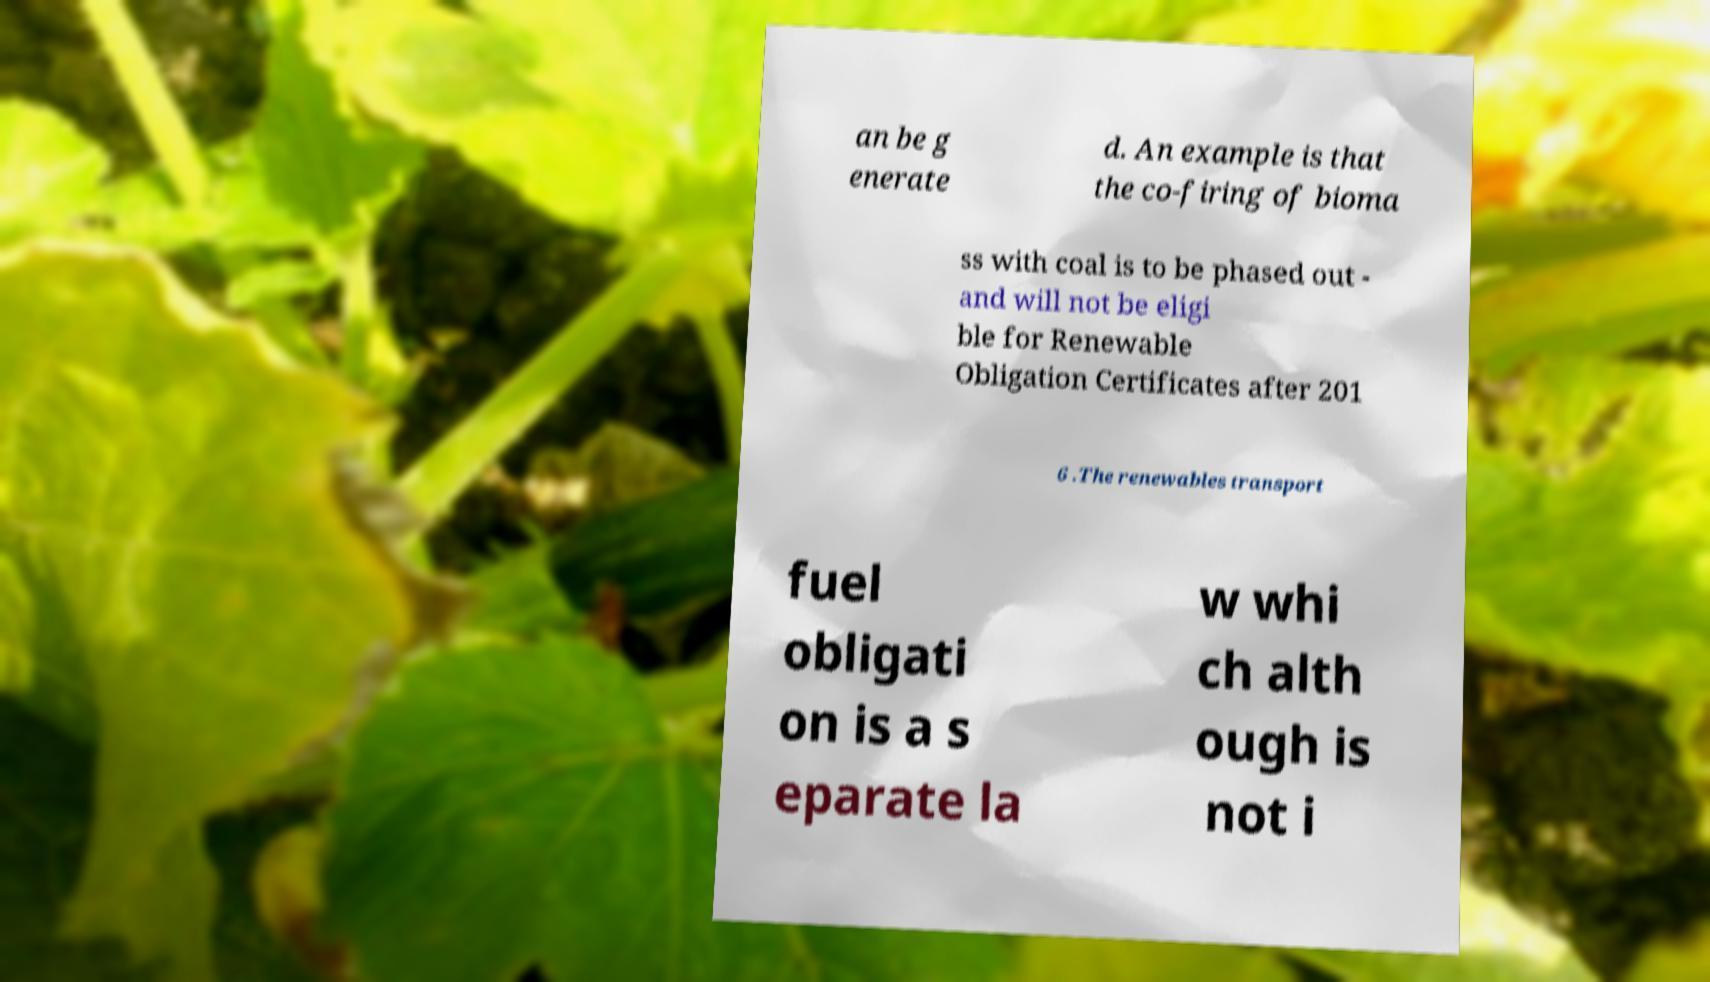For documentation purposes, I need the text within this image transcribed. Could you provide that? an be g enerate d. An example is that the co-firing of bioma ss with coal is to be phased out - and will not be eligi ble for Renewable Obligation Certificates after 201 6 .The renewables transport fuel obligati on is a s eparate la w whi ch alth ough is not i 